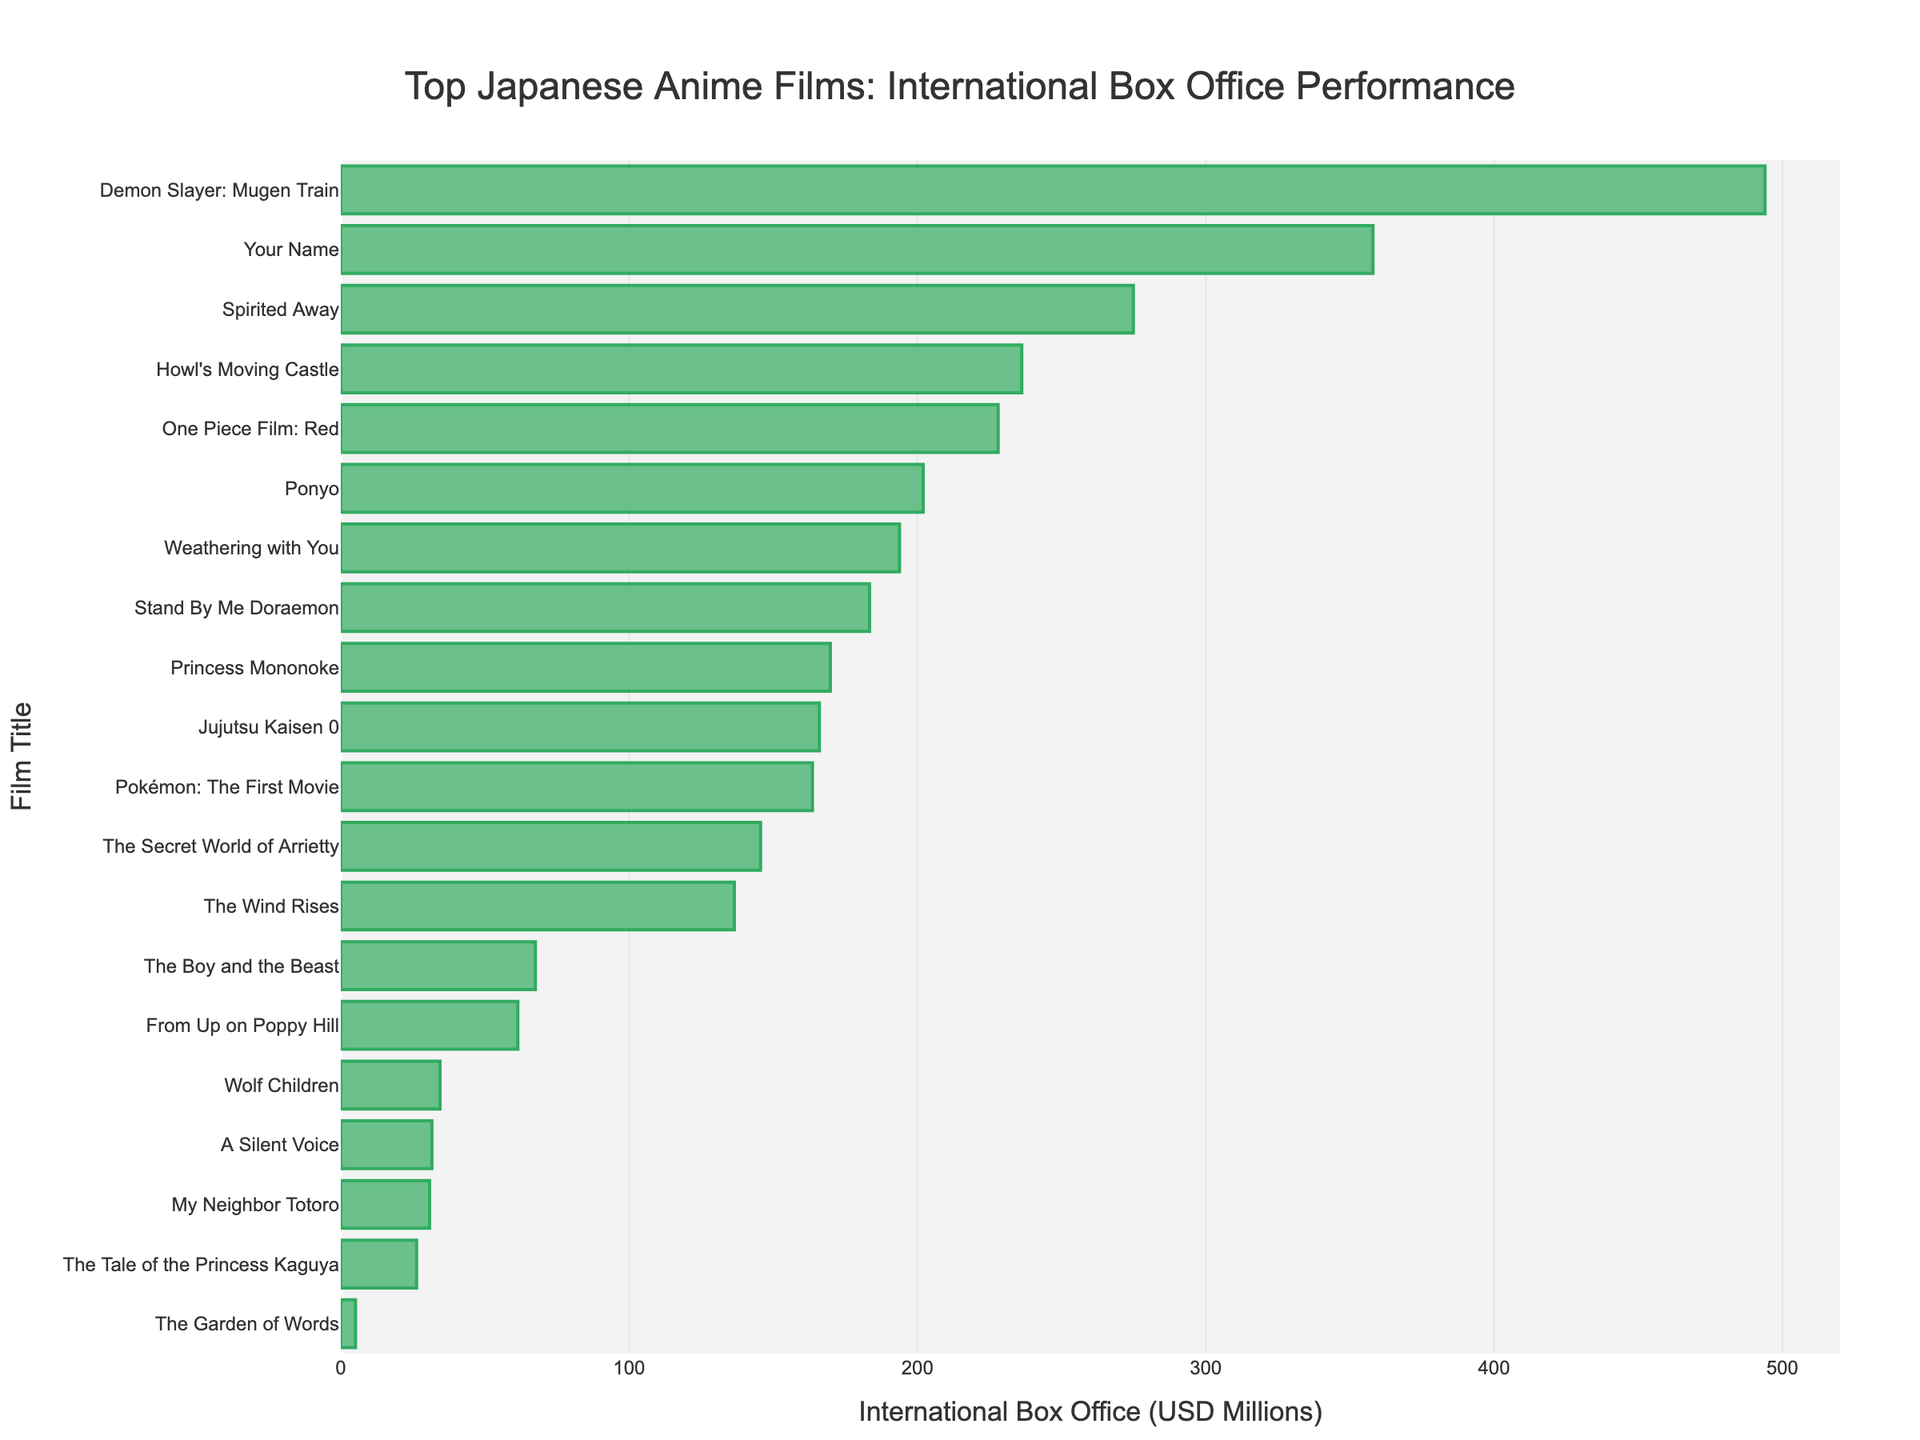What's the highest international box office performance among the listed Japanese anime films? The highest bar in the chart represents the film with the highest box office, which is "Demon Slayer: Mugen Train" at 494.0 million USD.
Answer: Demon Slayer: Mugen Train Which film performed better internationally, "Your Name" or "Spirited Away"? By comparing the lengths of the bars for "Your Name" (358.0 million USD) and "Spirited Away" (274.9 million USD), we can see that "Your Name" performed better internationally.
Answer: Your Name What is the total international box office performance of the top 3 films? The top 3 films are "Demon Slayer: Mugen Train" (494.0 million USD), "Your Name" (358.0 million USD), and "Spirited Away" (274.9 million USD). Summing these up: 494.0 + 358.0 + 274.9 = 1126.9 million USD.
Answer: 1126.9 million USD How much more did "Demon Slayer: Mugen Train" earn compared to "Howl's Moving Castle"? "Demon Slayer: Mugen Train" earned 494.0 million USD and "Howl's Moving Castle" earned 236.2 million USD. The difference is 494.0 - 236.2 = 257.8 million USD.
Answer: 257.8 million USD What is the average international box office performance of the films? Sum all the box office values and divide by the number of films. The sum is 494.0 + 358.0 + 274.9 + 236.2 + 202.0 + 136.5 + 169.8 + 193.8 + 183.4 + 67.5 + 30.8 + 163.6 + 26.3 + 145.6 + 61.4 + 34.4 + 5.1 + 31.6 + 228.0 + 166.0 = 3709.9 million USD. Number of films = 20. Average = 3709.9 / 20 = 185.5 million USD.
Answer: 185.5 million USD Which film had the lowest international box office performance? The shortest bar in the chart represents the film with the lowest box office, which is "The Garden of Words" at 5.1 million USD.
Answer: The Garden of Words Is "Princess Mononoke" above or below the average international box office performance? The average international box office performance is 185.5 million USD. "Princess Mononoke" earned 169.8 million USD, which is below the average.
Answer: Below average What is the difference between the international box office performances of "Weathering with You" and "Stand By Me Doraemon"? "Weathering with You" earned 193.8 million USD and "Stand By Me Doraemon" earned 183.4 million USD. The difference is 193.8 - 183.4 = 10.4 million USD.
Answer: 10.4 million USD How many films earned more than 200 million USD internationally? The films that earned more than 200 million USD are "Demon Slayer: Mugen Train" (494.0 million USD), "Your Name" (358.0 million USD), "Spirited Away" (274.9 million USD), "Howl's Moving Castle" (236.2 million USD), "Ponyo" (202.0 million USD), and "One Piece Film: Red" (228.0 million USD). There are 6 films in total.
Answer: 6 films Which film had an international box office performance closest to 150 million USD? Among the films, "The Secret World of Arrietty" earned 145.6 million USD, which is the closest to 150 million USD.
Answer: The Secret World of Arrietty 